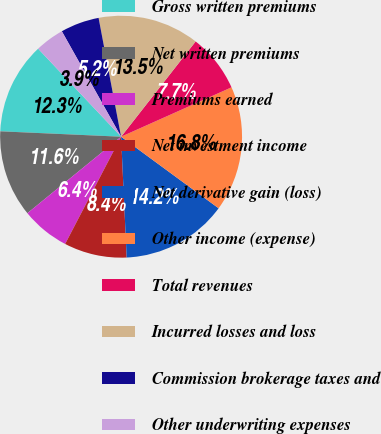<chart> <loc_0><loc_0><loc_500><loc_500><pie_chart><fcel>Gross written premiums<fcel>Net written premiums<fcel>Premiums earned<fcel>Net investment income<fcel>Net derivative gain (loss)<fcel>Other income (expense)<fcel>Total revenues<fcel>Incurred losses and loss<fcel>Commission brokerage taxes and<fcel>Other underwriting expenses<nl><fcel>12.26%<fcel>11.61%<fcel>6.45%<fcel>8.39%<fcel>14.19%<fcel>16.77%<fcel>7.74%<fcel>13.55%<fcel>5.17%<fcel>3.88%<nl></chart> 